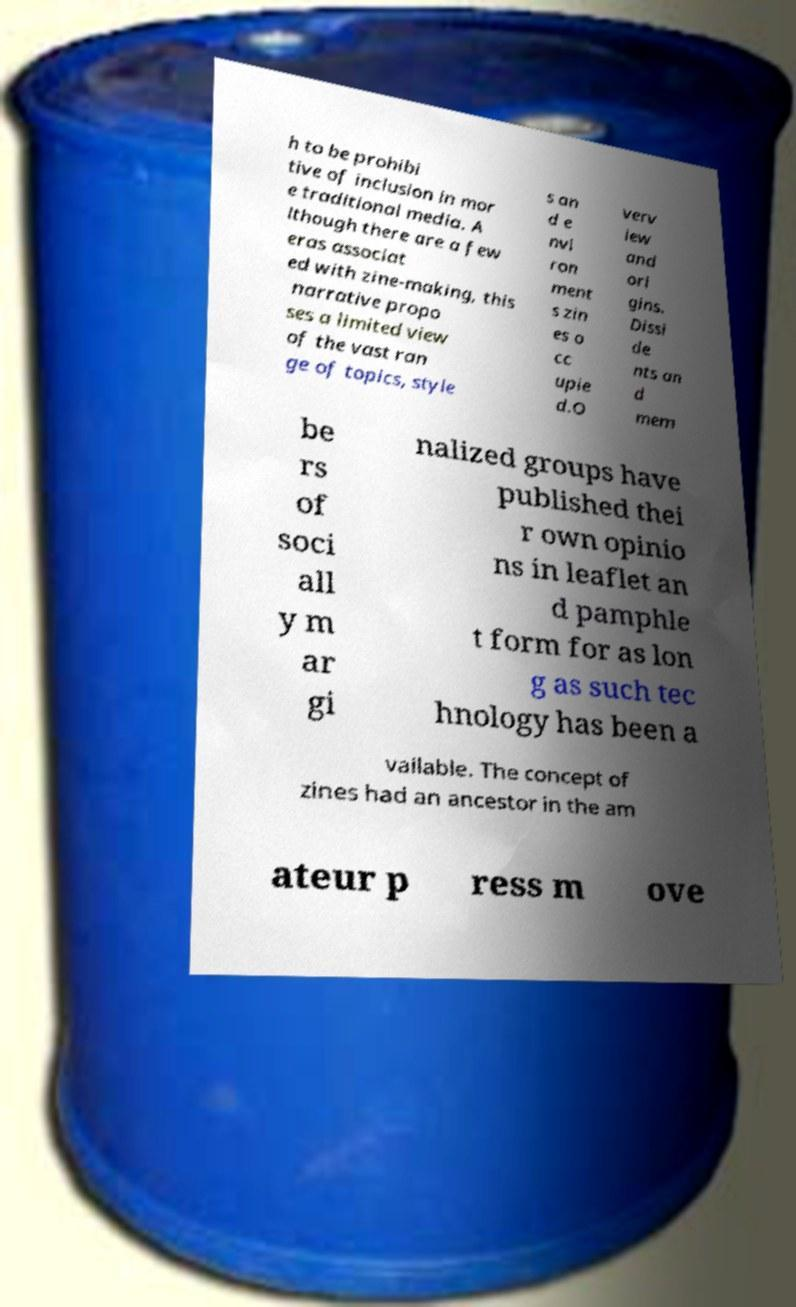Can you accurately transcribe the text from the provided image for me? h to be prohibi tive of inclusion in mor e traditional media. A lthough there are a few eras associat ed with zine-making, this narrative propo ses a limited view of the vast ran ge of topics, style s an d e nvi ron ment s zin es o cc upie d.O verv iew and ori gins. Dissi de nts an d mem be rs of soci all y m ar gi nalized groups have published thei r own opinio ns in leaflet an d pamphle t form for as lon g as such tec hnology has been a vailable. The concept of zines had an ancestor in the am ateur p ress m ove 